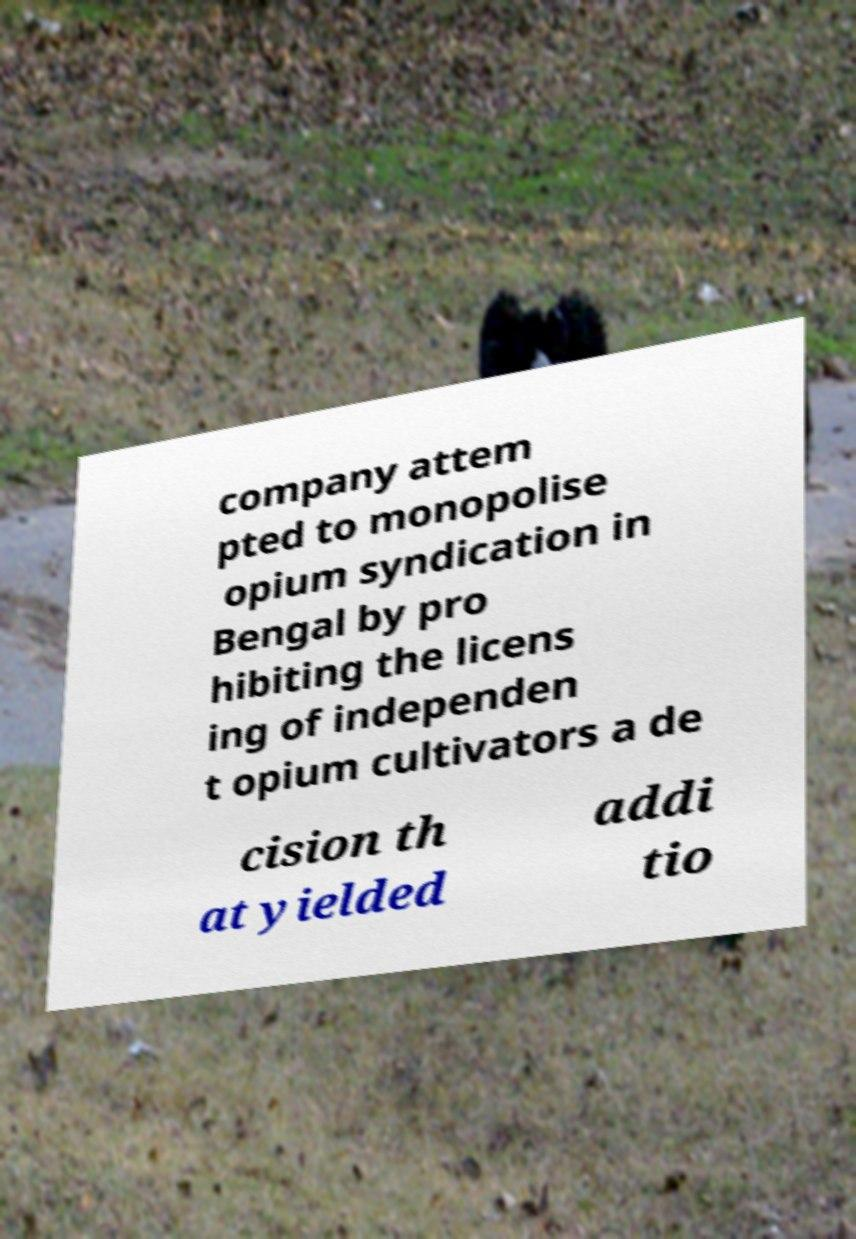There's text embedded in this image that I need extracted. Can you transcribe it verbatim? company attem pted to monopolise opium syndication in Bengal by pro hibiting the licens ing of independen t opium cultivators a de cision th at yielded addi tio 